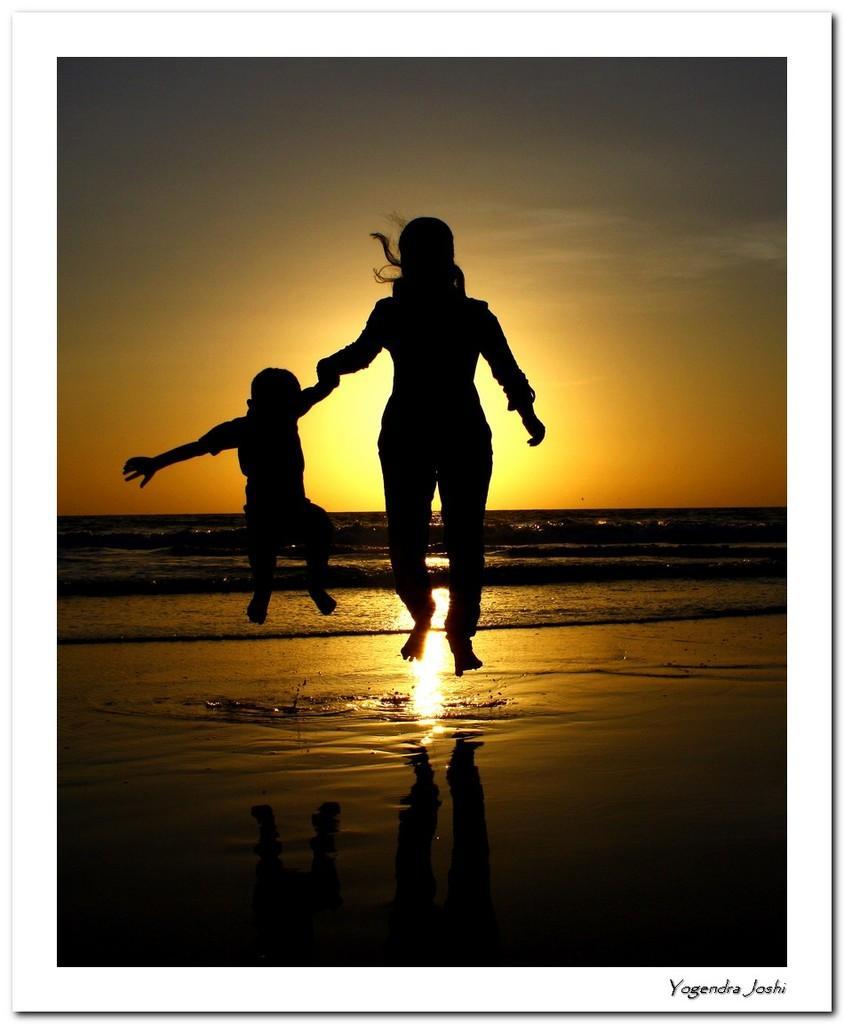Can you describe this image briefly? In this image there is a women and a kid jumping on a seashore, in the background there is a sea and a sunrise in the sky, in the bottom right there is text. 